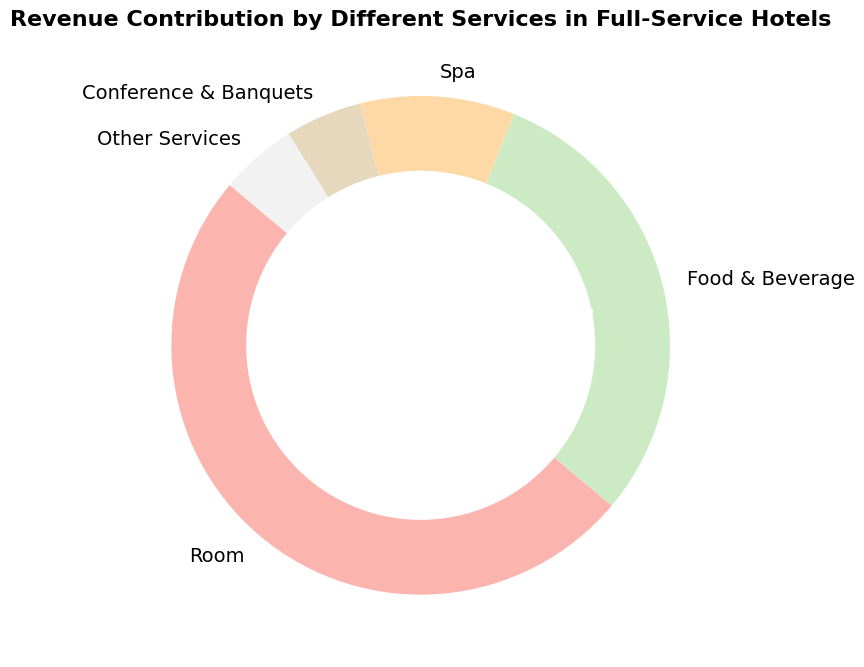What is the percentage contribution from the Room service? The figure shows different services with their corresponding percentage contributions. The segment labeled "Room" shows a contribution of 50%.
Answer: 50% Which service has the least revenue contribution? The figure illustrates several services and their respective contributions in percentage. Both "Conference & Banquets" and "Other Services" have the lowest contributions at 5%.
Answer: Conference & Banquets and Other Services How much more does the Room service contribute to the revenue compared to the Spa? Room service contributes 50% and Spa contributes 10%. The difference is calculated as 50% - 10%.
Answer: 40% What is the combined percentage contribution of Food & Beverage and Spa services? Food & Beverage service contributes 30% and Spa contributes 10%. Their combined contribution is calculated as 30% + 10%.
Answer: 40% Which service contributes three times more to the revenue than Spa? The Spa contributes 10%. The service contributing three times this amount is 3 * 10% = 30%, which corresponds to Food & Beverage.
Answer: Food & Beverage Does the combined contribution of Conference & Banquets and Other Services exceed the contribution from Spa? Conference & Banquets and Other Services contribute 5% each, totaling 5% + 5% = 10%. Spa also contributes 10%. Therefore, they do not exceed Spa's contribution.
Answer: No What is the average revenue contribution of all services? The contributions are 50%, 30%, 10%, 5%, and 5%. The average is calculated as (50% + 30% + 10% + 5% + 5%) / 5.
Answer: 20% Which services collectively contribute more than half of the total revenue? Room (50%) and Food & Beverage (30%) are the top contributors. The combined contributions of Room and Food & Beverage are 50% + 30% = 80%.
Answer: Room and Food & Beverage What is the difference in percentage contribution between Food & Beverage and Conference & Banquets? Food & Beverage contributes 30%, while Conference & Banquets contribute 5%. The difference is calculated as 30% - 5%.
Answer: 25% Which service segment, excluding the highest contributor, still covers one-quarter of the total revenue? Excluding Room at 50%, the next highest contributors are Food & Beverage (30%), Spa (10%), Conference & Banquets (5%), and Other Services (5%). Only Food & Beverage (30%) covers more than 25%.
Answer: Food & Beverage 